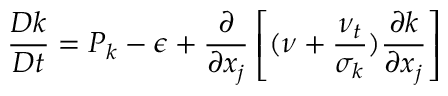<formula> <loc_0><loc_0><loc_500><loc_500>{ \frac { D k } { D t } } = P _ { k } - \epsilon + { \frac { \partial } { \partial x _ { j } } } \left [ ( \nu + { \frac { \nu _ { t } } { \sigma _ { k } } } ) { \frac { \partial k } { \partial x _ { j } } } \right ]</formula> 